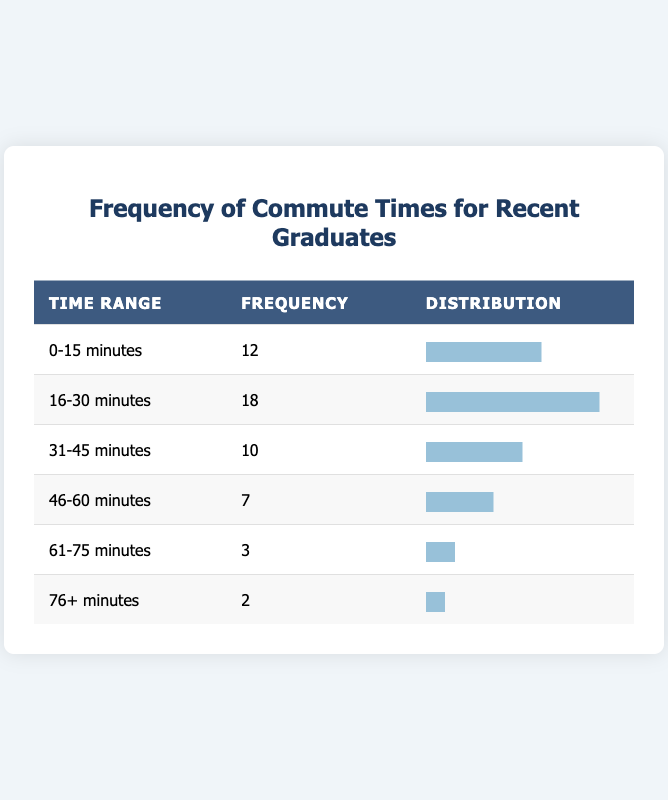What is the highest frequency of commute times? The table shows that the highest frequency is in the "16-30 minutes" time range with a frequency of 18.
Answer: 18 How many people commute for 45 minutes or more? To find this, we add the frequencies for the "46-60 minutes," "61-75 minutes," and "76+ minutes" categories: 7 + 3 + 2 = 12.
Answer: 12 Is the frequency of people commuting for 0-15 minutes greater than those commuting for 31-45 minutes? Yes, the frequency for "0-15 minutes" is 12, which is greater than the frequency for "31-45 minutes," which is 10.
Answer: Yes What is the total frequency of all commute times? We sum the frequencies from all categories: 12 + 18 + 10 + 7 + 3 + 2 = 52.
Answer: 52 What percentage of recent graduates commute for 61 minutes or more? We calculate the frequency for "61-75 minutes" and "76+ minutes," which is 3 + 2 = 5. The percentage is (5/52) * 100 = 9.62%.
Answer: 9.62% Which time range has the lowest frequency, and what is that frequency? The "76+ minutes" time range has the lowest frequency with a count of 2.
Answer: 2 Is it true that more than 50% of the surveyed graduates commute for 30 minutes or less? To check, we consider the frequencies for "0-15 minutes" (12) and "16-30 minutes" (18), totaling 30. Since 30 out of 52 (which is about 57.69%) is greater than 50%, the statement is true.
Answer: Yes What is the average frequency of the commute times? The average is calculated by dividing the total frequency (52) by the number of categories (6); thus, 52/6 = 8.67.
Answer: 8.67 